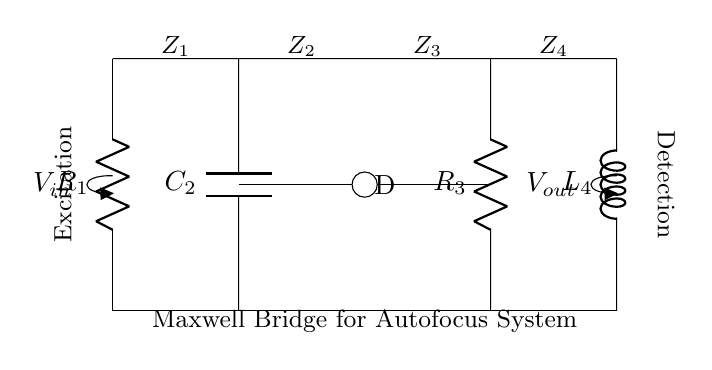What are the components in this circuit? The circuit consists of two resistors, one capacitor, and one inductor, labeled as R1, C2, R3, and L4, respectively.
Answer: resistors, capacitor, inductor What is the purpose of the inductor in this circuit? The inductor L4 is used in the Maxwell bridge configuration to balance the bridge by compensating the reactive component introduced by the capacitor C2, thus improving measurement accuracy.
Answer: balance What type of bridge is depicted in the circuit? This circuit is a Maxwell bridge, specifically used for measuring inductance.
Answer: Maxwell bridge How many nodes are in the circuit diagram? The diagram shows three nodes based on the intersection points of components where connections occur.
Answer: three What is the role of the voltage source in this circuit? The voltage source V_in provides the necessary excitation voltage to the circuit for the measurement process to occur, which is essential for the bridge to function correctly.
Answer: excitation voltage What is connected to point D in the diagram? Point D is connected to the junction of the capacitor C2 and resistor R3, serving as a measurement point in the circuit.
Answer: C2 and R3 What does V_out represent in this circuit? V_out represents the output voltage of the Maxwell bridge, which is collected after the balance is achieved for further analysis.
Answer: output voltage 